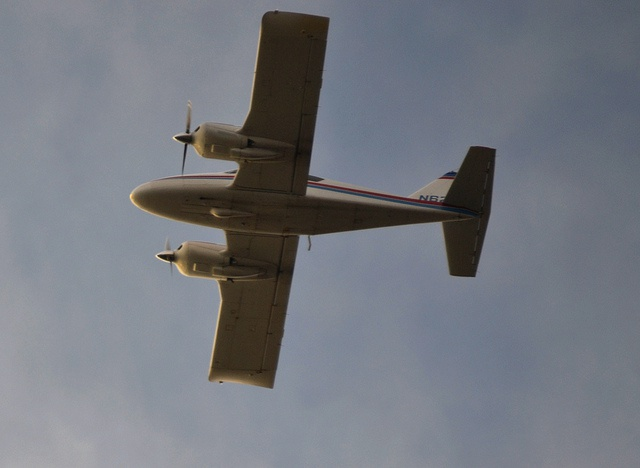Describe the objects in this image and their specific colors. I can see a airplane in gray and black tones in this image. 